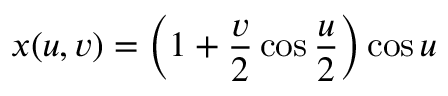<formula> <loc_0><loc_0><loc_500><loc_500>x ( u , v ) = \left ( 1 + { \frac { v } { 2 } } \cos { \frac { u } { 2 } } \right ) \cos u</formula> 